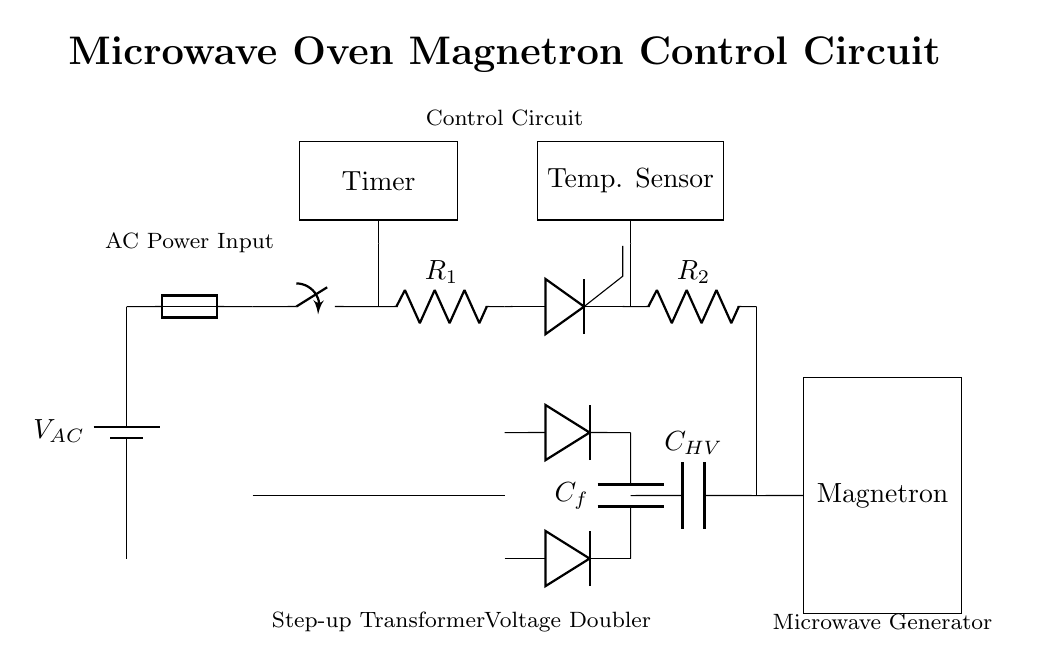What is the function of the transformer in this circuit? The transformer steps up the AC voltage from the power supply to a higher voltage necessary for the subsequent components, specifically the rectifier and magnetron.
Answer: Step-up What components are used in the control circuit? The control circuit consists of a switch, resistors, and a thyristor, which work together to control the operation of the magnetron by regulating the current flow.
Answer: Switch, resistors, thyristor What is the role of the high voltage capacitor? The high voltage capacitor stores electrical energy after being rectified and provides the necessary high voltage power to the magnetron for microwave generation.
Answer: Energy storage How many diodes are in the rectifier section? There are two diodes shown, which are configured in a voltage doubler circuit to convert AC voltage to DC voltage while also increasing the voltage level for the subsequent components.
Answer: Two What type of sensor is included in the circuit? The circuit includes a temperature sensor that likely monitors the temperature of the food being cooked, which can help adjust cooking time and power levels based on the food's temperature.
Answer: Temperature sensor How does the timer affect the control circuit? The timer is crucial for controlling the duration of the cooking cycle; it regulates the operation of the switch to turn the magnetron on and off, thus controlling the microwave cooking time.
Answer: Duration control What does the label "Microwave Generator" refer to? The label refers to the magnetron, which is the primary component responsible for generating high-frequency electromagnetic waves used for cooking in a microwave oven.
Answer: Magnetron 